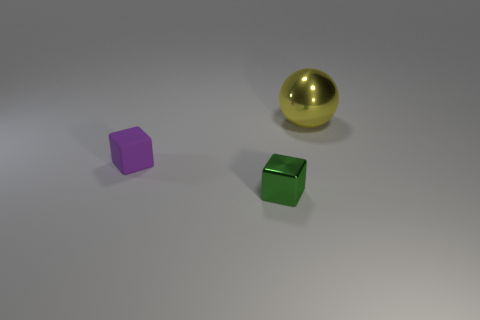Add 1 purple things. How many objects exist? 4 Subtract all spheres. How many objects are left? 2 Add 2 small cubes. How many small cubes are left? 4 Add 2 tiny green metal objects. How many tiny green metal objects exist? 3 Subtract 0 brown cylinders. How many objects are left? 3 Subtract all small green metal balls. Subtract all large yellow shiny spheres. How many objects are left? 2 